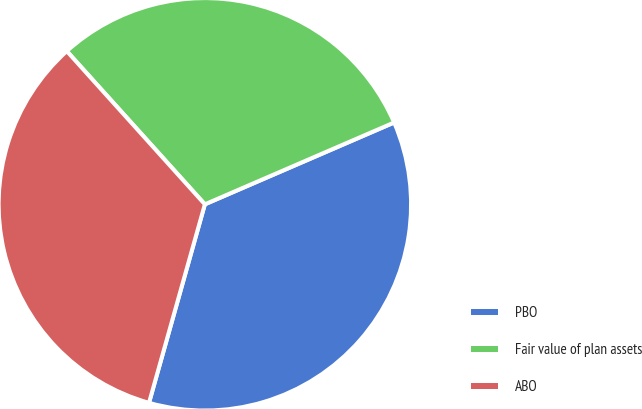<chart> <loc_0><loc_0><loc_500><loc_500><pie_chart><fcel>PBO<fcel>Fair value of plan assets<fcel>ABO<nl><fcel>35.86%<fcel>30.18%<fcel>33.96%<nl></chart> 